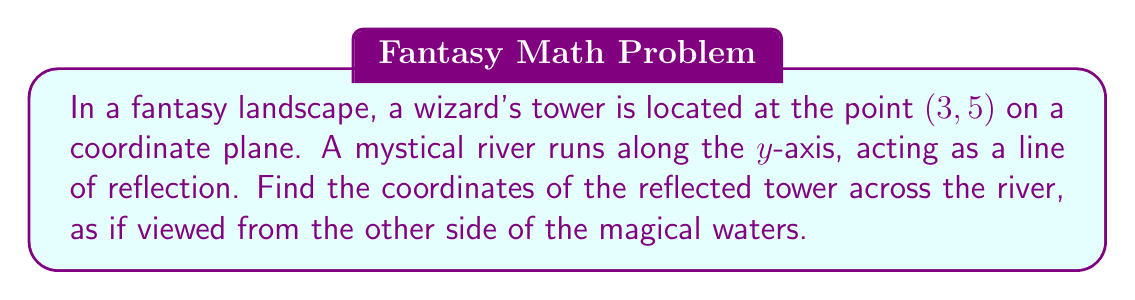What is the answer to this math problem? To solve this problem, we need to understand the concept of reflection across the y-axis in coordinate geometry. When reflecting a point across the y-axis:

1. The y-coordinate remains unchanged.
2. The x-coordinate changes sign (positive becomes negative and vice versa).

Let's follow these steps:

1. Identify the original coordinates:
   The wizard's tower is at (3, 5)

2. Reflect across the y-axis:
   - The x-coordinate (3) changes sign: 3 → -3
   - The y-coordinate (5) remains the same: 5 → 5

3. Write the new coordinates:
   The reflected tower's coordinates are (-3, 5)

Visually, we can represent this as:

[asy]
import graph;
size(200);
xaxis("x", -5, 5, arrow=Arrow);
yaxis("y", -1, 6, arrow=Arrow);
dot((3,5), red);
dot((-3,5), blue);
label("(3, 5)", (3,5), NE, red);
label("(-3, 5)", (-3,5), NW, blue);
label("River (y-axis)", (0,5.5), N);
draw((0,-1)--(0,6), dashed);
[/asy]

This diagram shows the original tower (red) and its reflection (blue) across the mystical river (y-axis).
Answer: The coordinates of the reflected wizard's tower are $(-3, 5)$. 